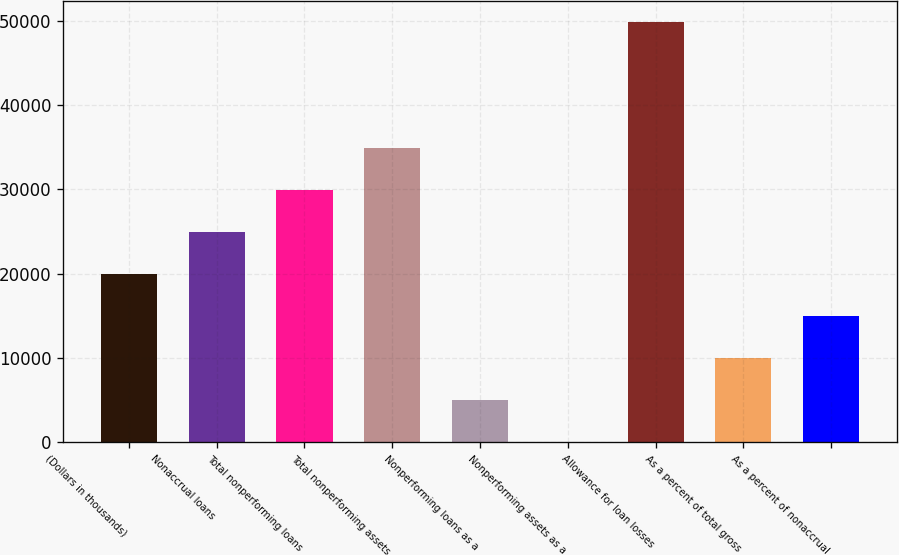Convert chart to OTSL. <chart><loc_0><loc_0><loc_500><loc_500><bar_chart><fcel>(Dollars in thousands)<fcel>Nonaccrual loans<fcel>Total nonperforming loans<fcel>Total nonperforming assets<fcel>Nonperforming loans as a<fcel>Nonperforming assets as a<fcel>Allowance for loan losses<fcel>As a percent of total gross<fcel>As a percent of nonaccrual<nl><fcel>19945<fcel>24931.1<fcel>29917.3<fcel>34903.5<fcel>4986.45<fcel>0.28<fcel>49862<fcel>9972.62<fcel>14958.8<nl></chart> 